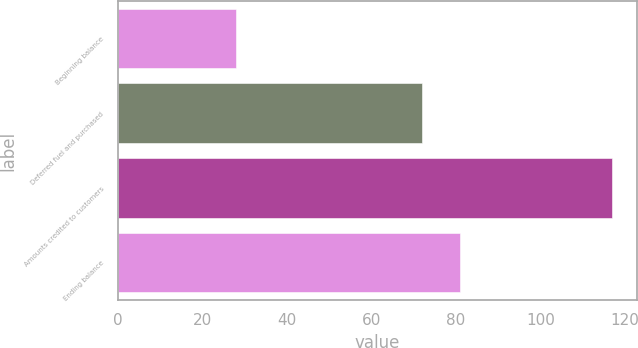Convert chart. <chart><loc_0><loc_0><loc_500><loc_500><bar_chart><fcel>Beginning balance<fcel>Deferred fuel and purchased<fcel>Amounts credited to customers<fcel>Ending balance<nl><fcel>28<fcel>72<fcel>117<fcel>80.9<nl></chart> 